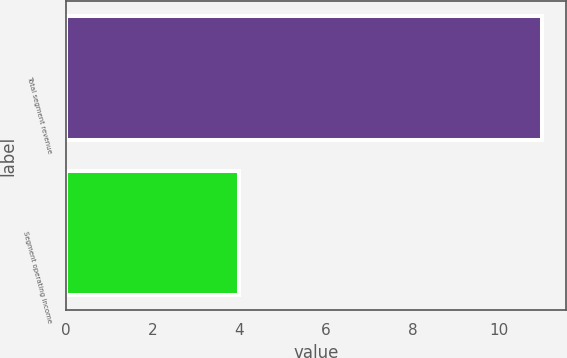Convert chart to OTSL. <chart><loc_0><loc_0><loc_500><loc_500><bar_chart><fcel>Total segment revenue<fcel>Segment operating income<nl><fcel>11<fcel>4<nl></chart> 